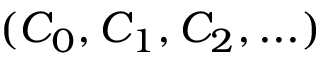Convert formula to latex. <formula><loc_0><loc_0><loc_500><loc_500>( C _ { 0 } , C _ { 1 } , C _ { 2 } , \dots )</formula> 